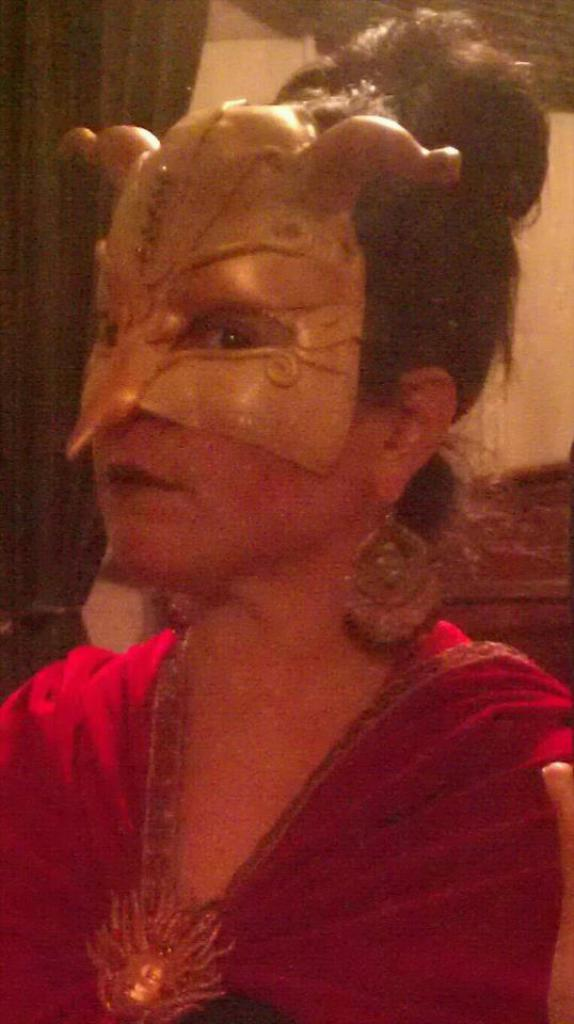Who is the main subject in the image? There is a woman in the image. What is the woman wearing? The woman is wearing a red dress and a mask. What can be seen in the background of the image? There is a wall and a curtain in the background of the image. What is the woman's income in the image? There is no information about the woman's income in the image. What force is being applied to the wall in the image? There is no force being applied to the wall in the image; it is stationary in the background. 